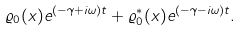Convert formula to latex. <formula><loc_0><loc_0><loc_500><loc_500>\varrho _ { 0 } ( x ) { e } ^ { ( - \gamma + i \omega ) t } + \varrho _ { 0 } ^ { * } ( x ) { e } ^ { ( - \gamma - i \omega ) t } .</formula> 